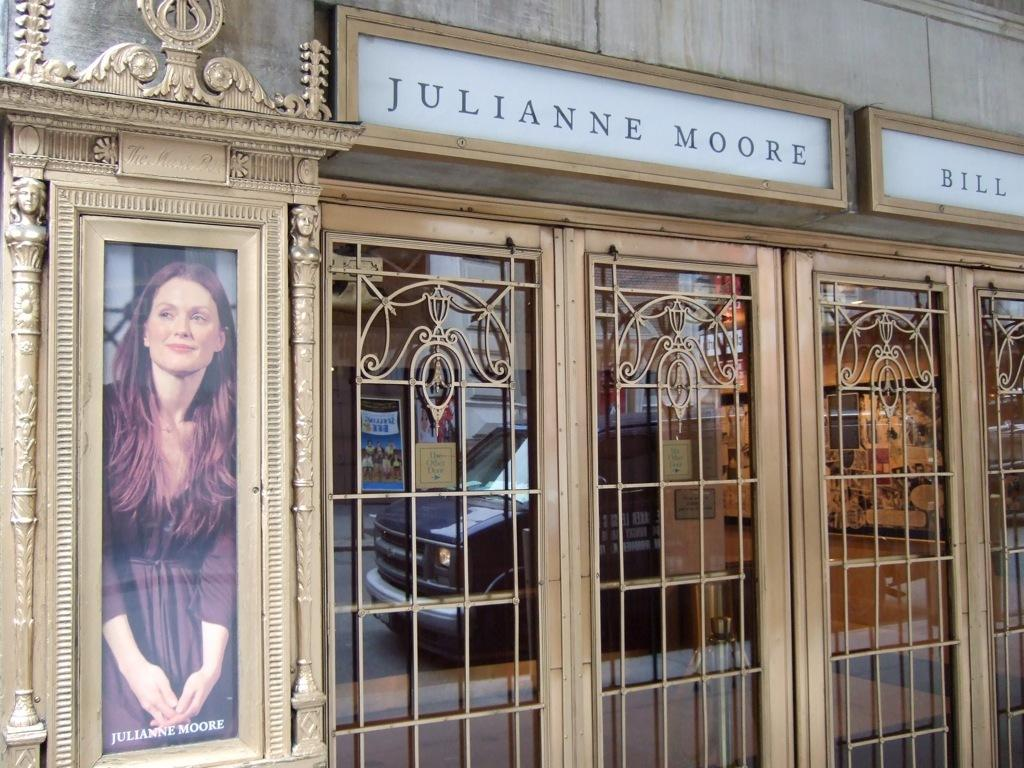<image>
Give a short and clear explanation of the subsequent image. A picture of Julianne Moore is displayed outside of two gold doors 